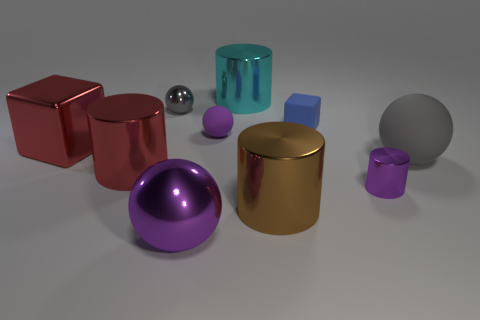Can you describe the colors and materials of the objects in the image? Certainly! The image contains objects of various colors and materials. There's a shiny red metallic cube, a reflective purple metal sphere, a gold metallic cylinder, a translucent blue cylinder, a solid blue cube, a small purple matte cylinder, a shiny small silver sphere, and a large gray matte sphere. 